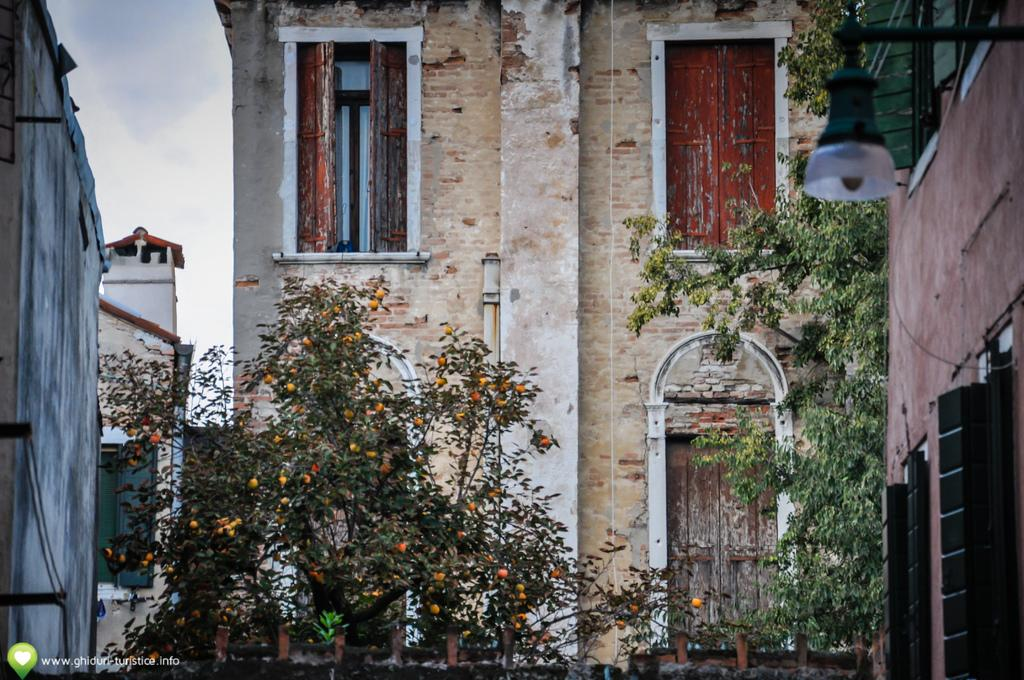What type of structure is present in the image? There is a building in the image. What features can be seen on the building? The building has a window and a door. What is located at the bottom of the image? There are plants at the bottom of the image. What is visible at the top of the image? The sky is visible at the top of the image. What type of linen is being used to cover the window in the image? There is no linen present in the image, nor is there any indication of a window covering. 